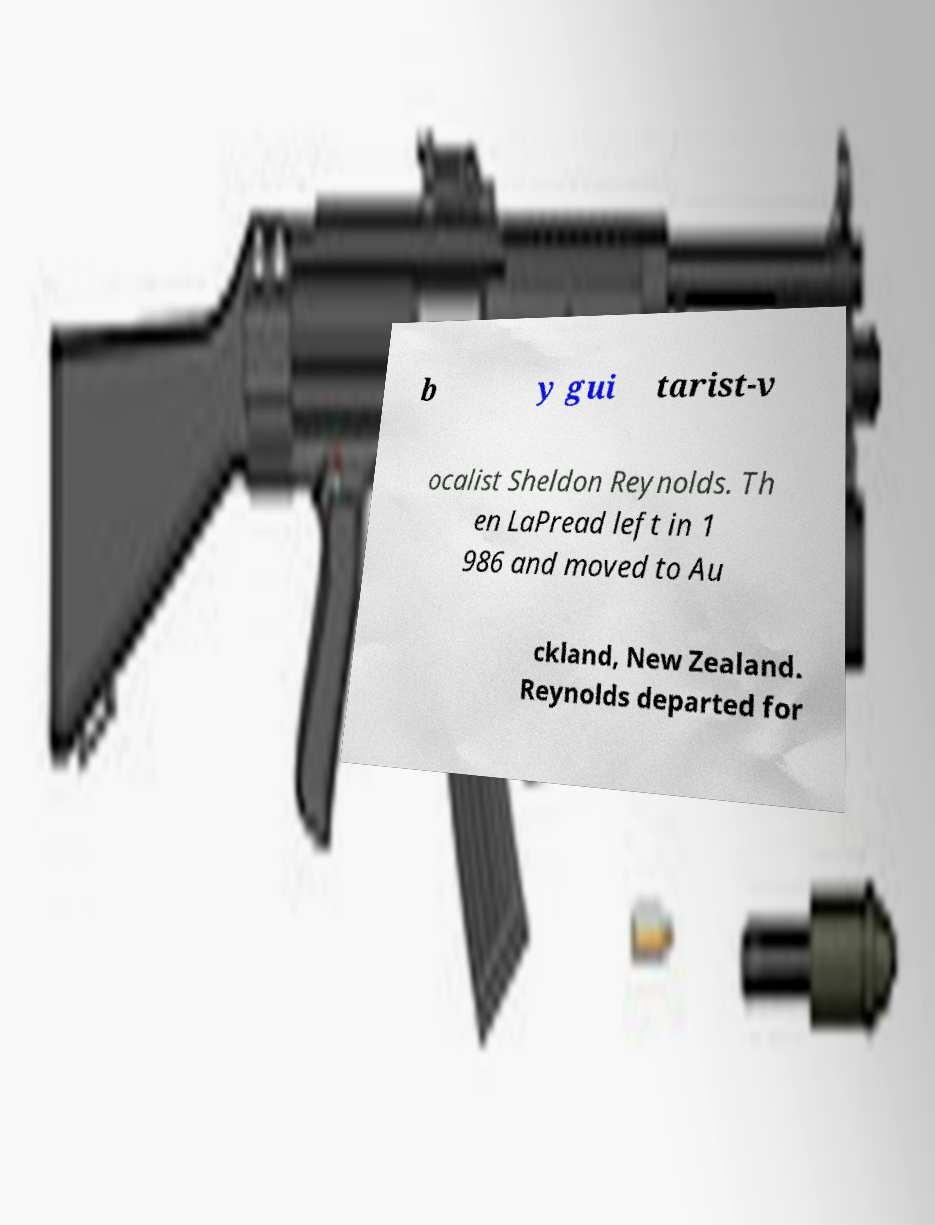Can you accurately transcribe the text from the provided image for me? b y gui tarist-v ocalist Sheldon Reynolds. Th en LaPread left in 1 986 and moved to Au ckland, New Zealand. Reynolds departed for 